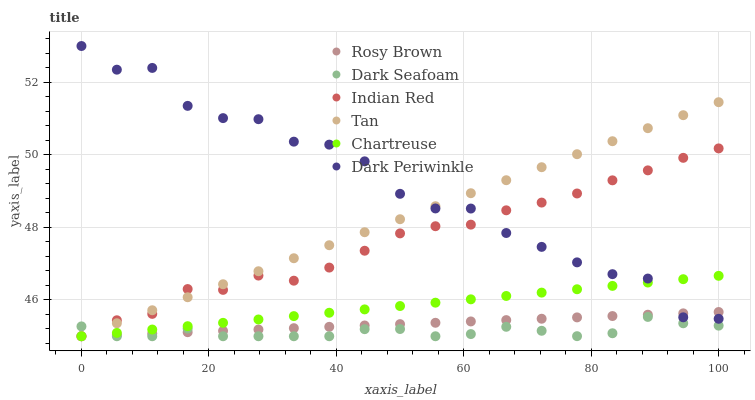Does Dark Seafoam have the minimum area under the curve?
Answer yes or no. Yes. Does Dark Periwinkle have the maximum area under the curve?
Answer yes or no. Yes. Does Chartreuse have the minimum area under the curve?
Answer yes or no. No. Does Chartreuse have the maximum area under the curve?
Answer yes or no. No. Is Tan the smoothest?
Answer yes or no. Yes. Is Dark Periwinkle the roughest?
Answer yes or no. Yes. Is Dark Seafoam the smoothest?
Answer yes or no. No. Is Dark Seafoam the roughest?
Answer yes or no. No. Does Rosy Brown have the lowest value?
Answer yes or no. Yes. Does Dark Periwinkle have the lowest value?
Answer yes or no. No. Does Dark Periwinkle have the highest value?
Answer yes or no. Yes. Does Chartreuse have the highest value?
Answer yes or no. No. Is Dark Seafoam less than Dark Periwinkle?
Answer yes or no. Yes. Is Dark Periwinkle greater than Dark Seafoam?
Answer yes or no. Yes. Does Dark Periwinkle intersect Indian Red?
Answer yes or no. Yes. Is Dark Periwinkle less than Indian Red?
Answer yes or no. No. Is Dark Periwinkle greater than Indian Red?
Answer yes or no. No. Does Dark Seafoam intersect Dark Periwinkle?
Answer yes or no. No. 